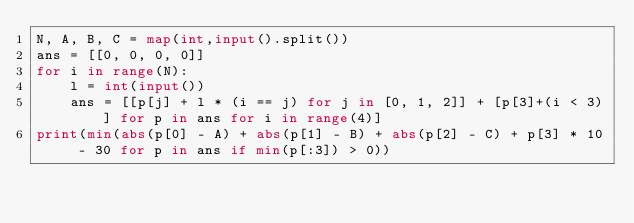Convert code to text. <code><loc_0><loc_0><loc_500><loc_500><_Python_>N, A, B, C = map(int,input().split())
ans = [[0, 0, 0, 0]]
for i in range(N):
    l = int(input())
    ans = [[p[j] + l * (i == j) for j in [0, 1, 2]] + [p[3]+(i < 3)] for p in ans for i in range(4)]
print(min(abs(p[0] - A) + abs(p[1] - B) + abs(p[2] - C) + p[3] * 10 - 30 for p in ans if min(p[:3]) > 0))</code> 